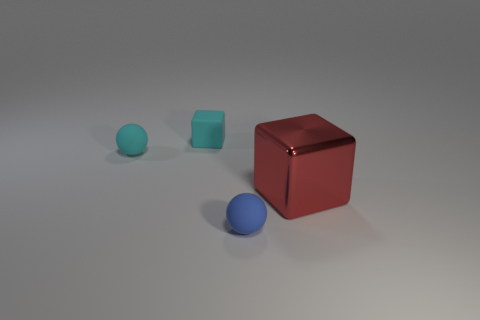Subtract 0 purple cubes. How many objects are left? 4 Subtract all gray balls. Subtract all purple blocks. How many balls are left? 2 Subtract all gray cylinders. How many green balls are left? 0 Subtract all small rubber blocks. Subtract all blue matte things. How many objects are left? 2 Add 2 small blue matte balls. How many small blue matte balls are left? 3 Add 1 blue shiny spheres. How many blue shiny spheres exist? 1 Add 2 small brown matte cubes. How many objects exist? 6 Subtract all cyan balls. How many balls are left? 1 